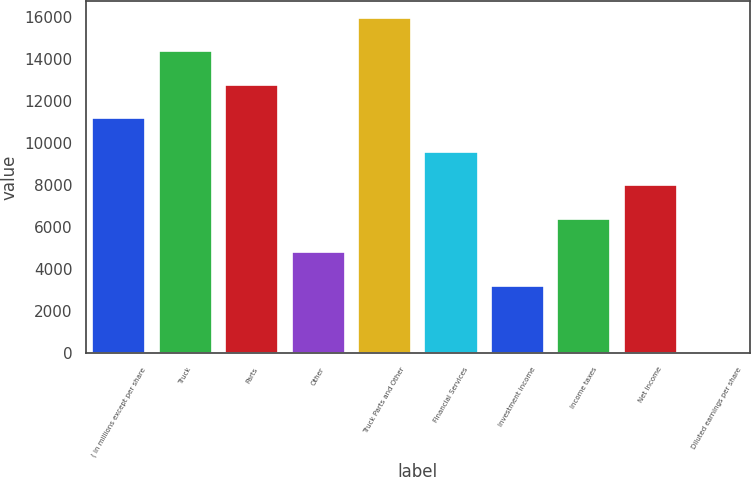<chart> <loc_0><loc_0><loc_500><loc_500><bar_chart><fcel>( in millions except per share<fcel>Truck<fcel>Parts<fcel>Other<fcel>Truck Parts and Other<fcel>Financial Services<fcel>Investment income<fcel>Income taxes<fcel>Net Income<fcel>Diluted earnings per share<nl><fcel>11165.2<fcel>14354.3<fcel>12759.8<fcel>4786.98<fcel>15948.9<fcel>9570.66<fcel>3192.42<fcel>6381.54<fcel>7976.1<fcel>3.3<nl></chart> 